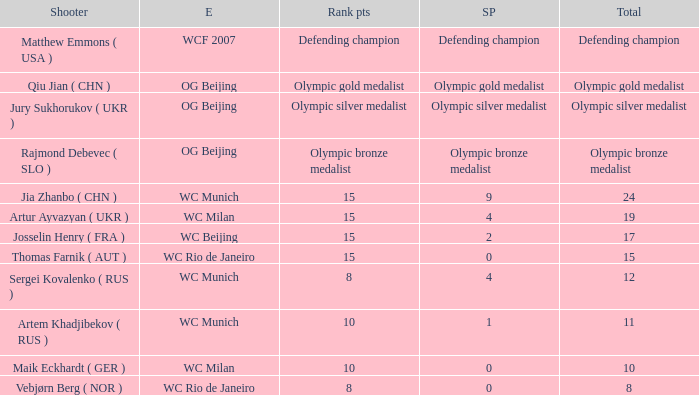Who was the shooter for the WC Beijing event? Josselin Henry ( FRA ). 